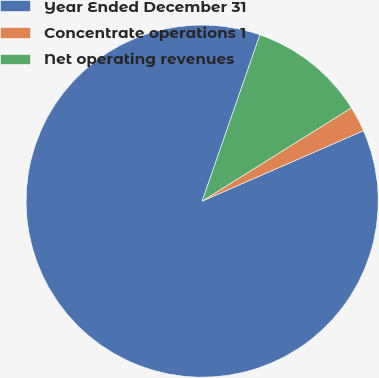<chart> <loc_0><loc_0><loc_500><loc_500><pie_chart><fcel>Year Ended December 31<fcel>Concentrate operations 1<fcel>Net operating revenues<nl><fcel>86.88%<fcel>2.34%<fcel>10.79%<nl></chart> 